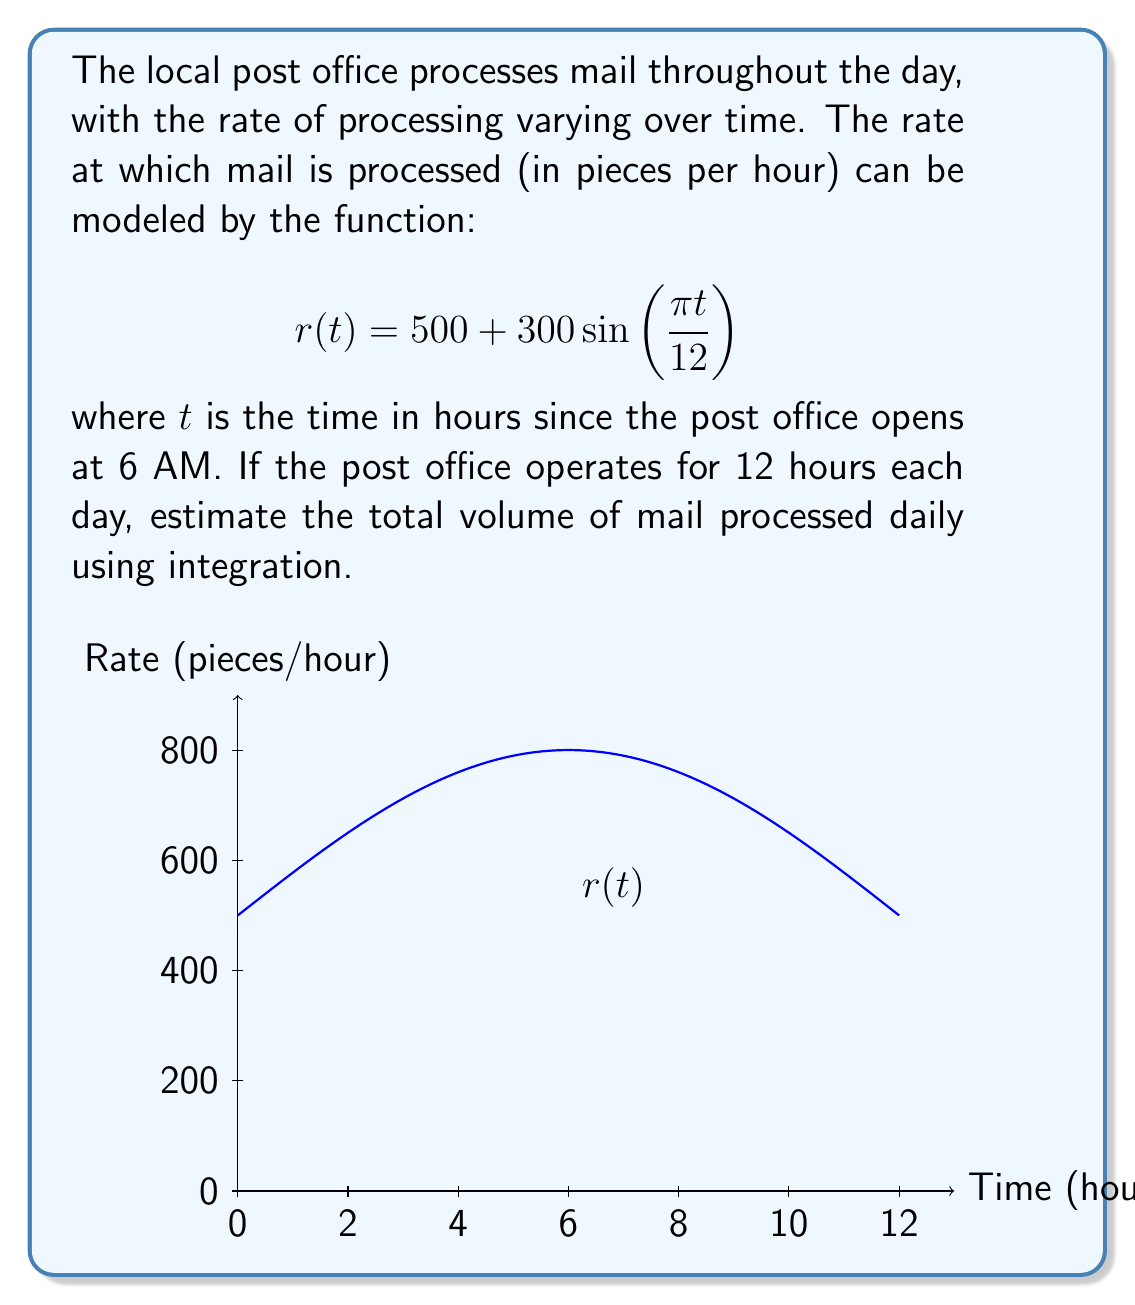Could you help me with this problem? To estimate the total volume of mail processed daily, we need to integrate the rate function over the 12-hour period. Here's the step-by-step solution:

1) The total volume of mail is the area under the rate curve, which can be found using a definite integral:

   $$V = \int_0^{12} r(t) dt$$

2) Substituting the given function:

   $$V = \int_0^{12} \left(500 + 300\sin\left(\frac{\pi t}{12}\right)\right) dt$$

3) We can split this into two integrals:

   $$V = \int_0^{12} 500 dt + \int_0^{12} 300\sin\left(\frac{\pi t}{12}\right) dt$$

4) The first integral is straightforward:

   $$\int_0^{12} 500 dt = 500t \Big|_0^{12} = 6000$$

5) For the second integral, we use the substitution $u = \frac{\pi t}{12}$:

   $$\int_0^{12} 300\sin\left(\frac{\pi t}{12}\right) dt = \frac{3600}{\pi} \int_0^{\pi} \sin(u) du$$

6) Evaluating this integral:

   $$\frac{3600}{\pi} \int_0^{\pi} \sin(u) du = \frac{3600}{\pi} [-\cos(u)]_0^{\pi} = \frac{3600}{\pi} \cdot 2 = \frac{7200}{\pi}$$

7) Adding the results from steps 4 and 6:

   $$V = 6000 + \frac{7200}{\pi} \approx 8291.83$$

Therefore, the estimated total volume of mail processed daily is approximately 8,292 pieces.
Answer: Approximately 8,292 pieces of mail 